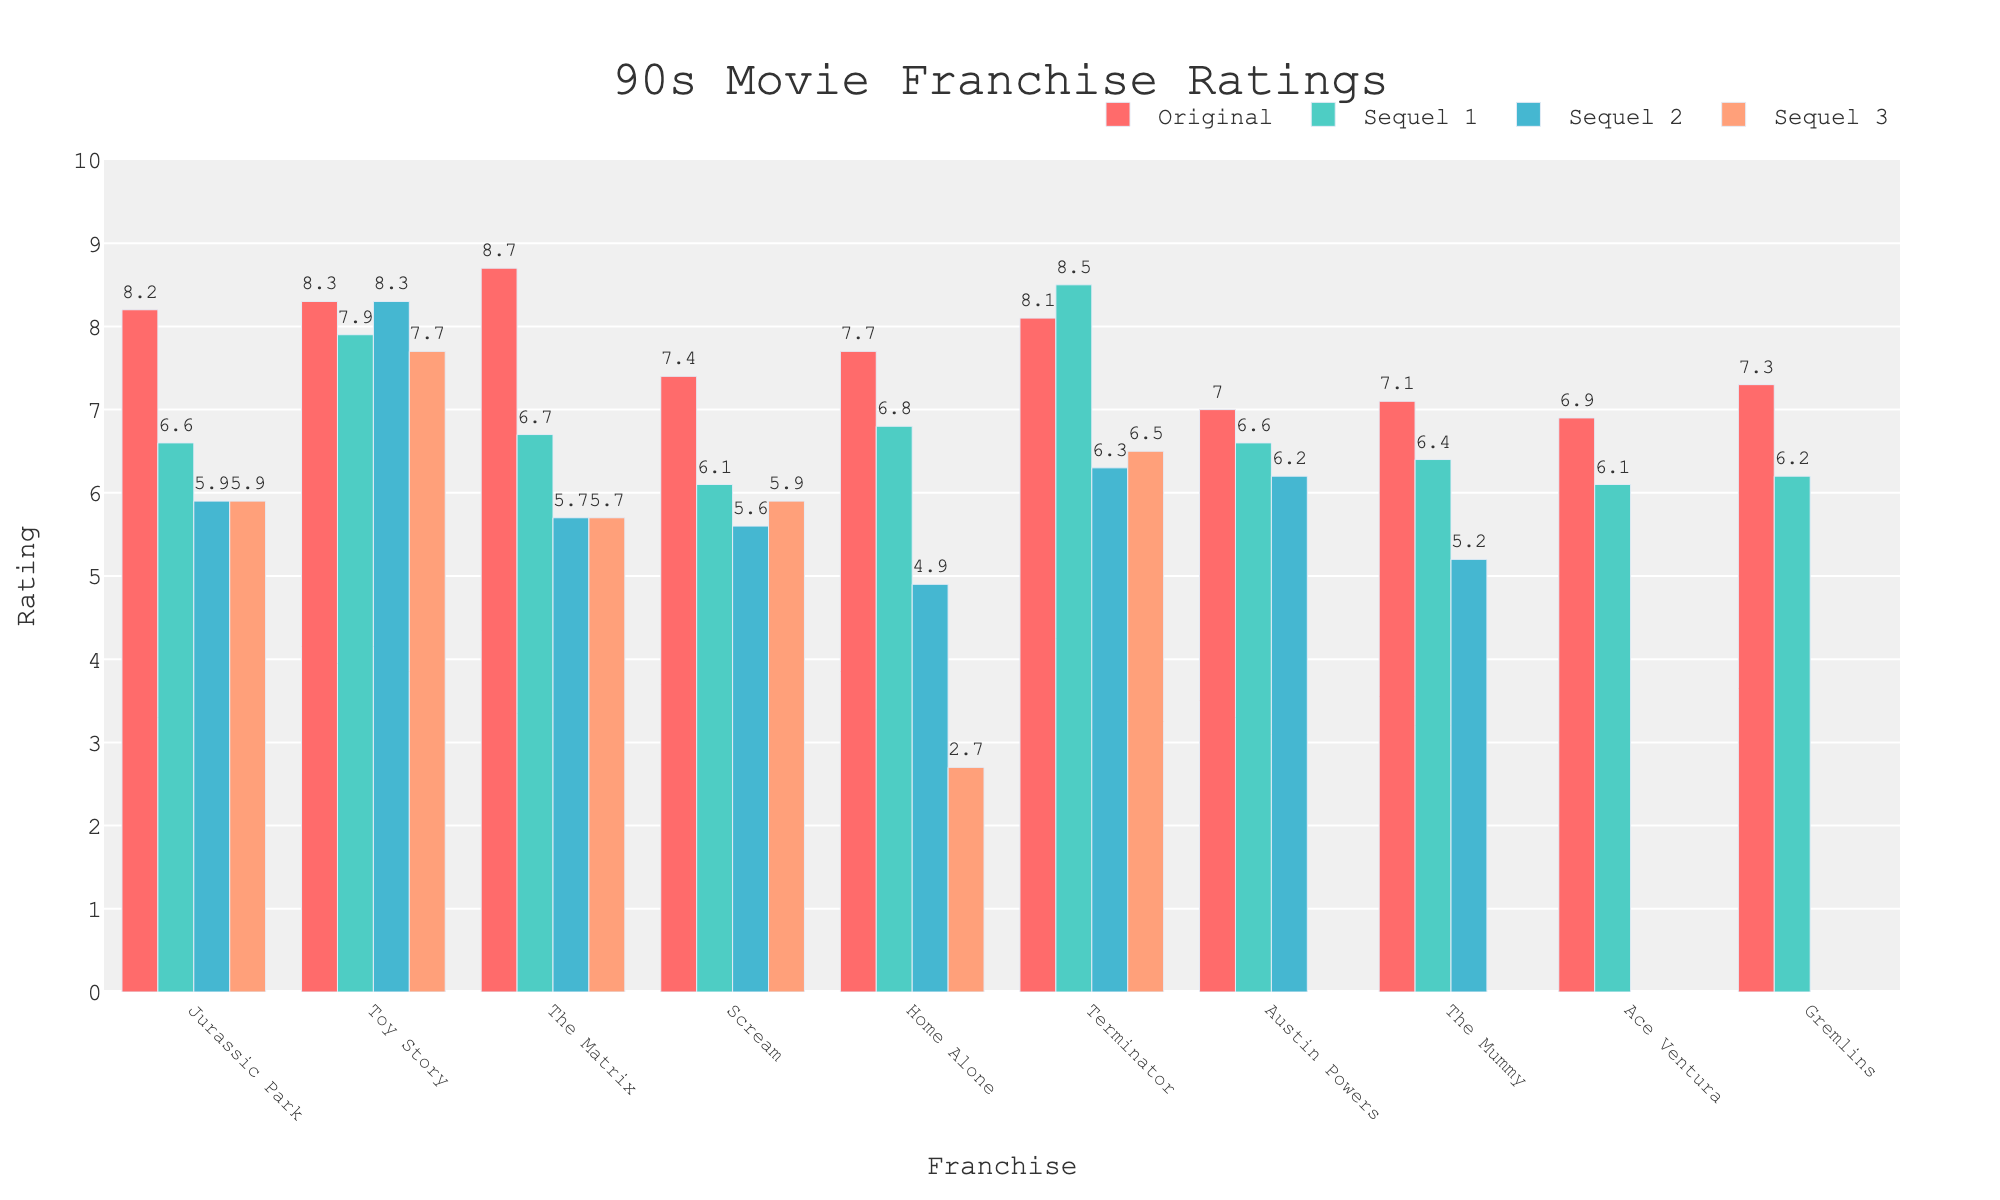Which franchise has the highest rating for its sequel 1? To determine this, look for the highest bar in the Sequel 1 category. 'Terminator' has the highest rating bar for Sequel 1 with a rating of 8.5.
Answer: Terminator What is the difference in ratings between the original "Jurassic Park" and "The Matrix"? Compare the heights of the bars for the original movies. 'Jurassic Park' has a rating of 8.2, and 'The Matrix' has a rating of 8.7. The difference is 8.7 - 8.2.
Answer: 0.5 Which franchise shows a consistent drop in ratings with each sequel? Examine the trend line of the bars in each franchise; look for bars consistently decreasing in height. 'The Matrix' has a consistent drop: Original (8.7), Sequel 1 (6.7), Sequel 2 (5.7), Sequel 3 (5.7).
Answer: The Matrix How many franchises do not have a Sequel 3 rating available? Look for franchises that have gaps or missing bars in the Sequel 3 category. 'Austin Powers', 'The Mummy', 'Ace Ventura', and 'Gremlins' do not have Sequel 3 ratings, making it a total of 4.
Answer: 4 Which sequel has the lowest rating across all franchises? Find the shortest bar in the chart, focusing on sequels only. Sequel 3 of ‘Home Alone’ has the lowest rating, which is 2.7.
Answer: Home Alone (Sequel 3) What’s the average rating of the original movies across all franchises? Add up the ratings of the Original movies and divide by the number of franchises. Total ratings sum = 8.2 + 8.3 + 8.7 + 7.4 + 7.7 + 8.1 + 7.0 + 7.1 + 6.9 + 7.3 = 76.7. Divide by 10 (number of franchises): 76.7/10.
Answer: 7.67 Which franchise has the largest drop in rating from the original to Sequel 2? Calculate the rating difference between the Original and Sequel 2 for each franchise and find the maximum drop. 'Home Alone' has the largest drop: Original (7.7) to Sequel 2 (4.9), the difference is 2.8.
Answer: Home Alone Which franchise’s sequels have a collective rating equal to or higher than their original movie rating? For each franchise, sum up the ratings of all its sequels and compare to the original rating. 'Toy Story' has Original (8.3) and sequels' sum (7.9 + 8.3 + 7.7) = 23.9 which is higher than 8.3.
Answer: Toy Story 